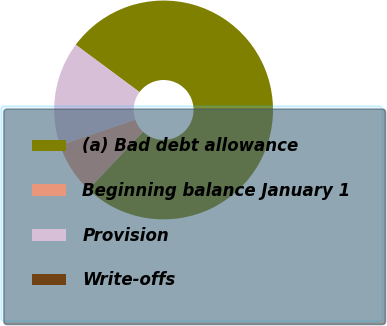Convert chart to OTSL. <chart><loc_0><loc_0><loc_500><loc_500><pie_chart><fcel>(a) Bad debt allowance<fcel>Beginning balance January 1<fcel>Provision<fcel>Write-offs<nl><fcel>76.91%<fcel>7.7%<fcel>15.39%<fcel>0.01%<nl></chart> 